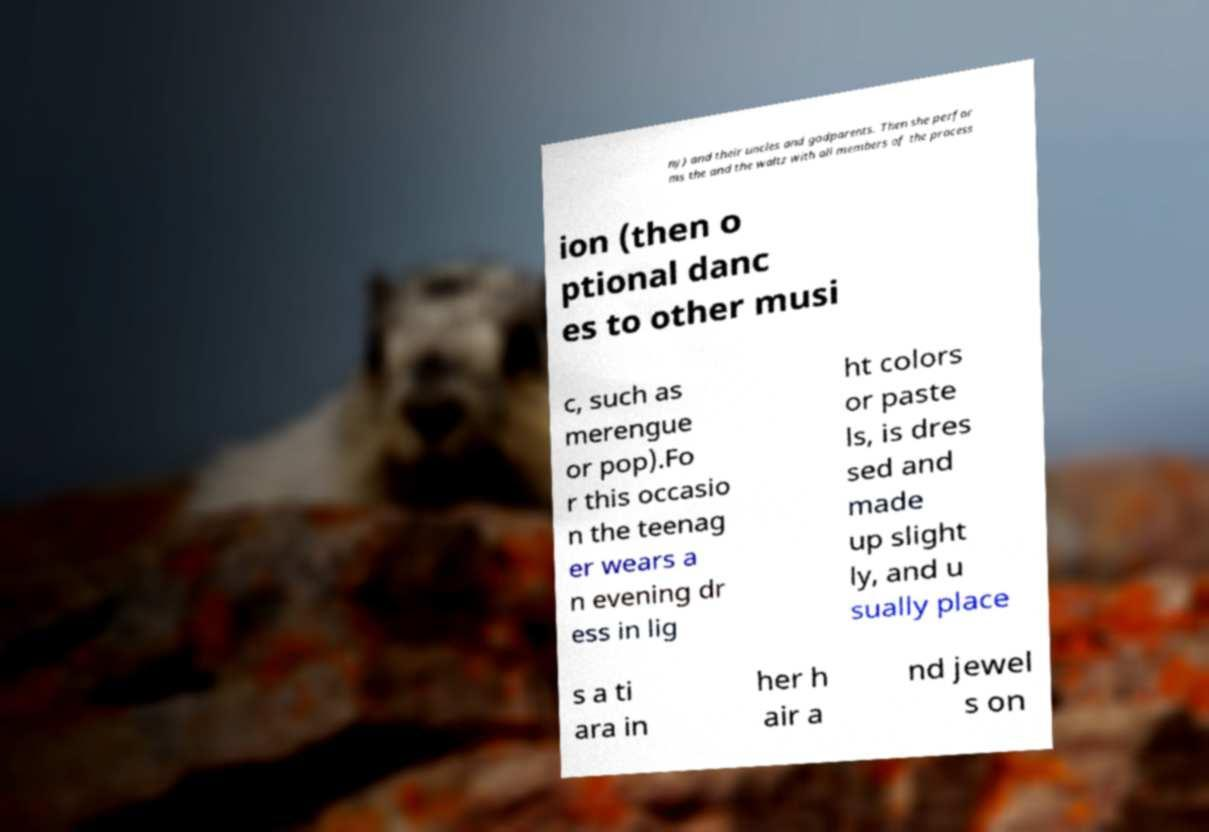Can you read and provide the text displayed in the image?This photo seems to have some interesting text. Can you extract and type it out for me? ny) and their uncles and godparents. Then she perfor ms the and the waltz with all members of the process ion (then o ptional danc es to other musi c, such as merengue or pop).Fo r this occasio n the teenag er wears a n evening dr ess in lig ht colors or paste ls, is dres sed and made up slight ly, and u sually place s a ti ara in her h air a nd jewel s on 